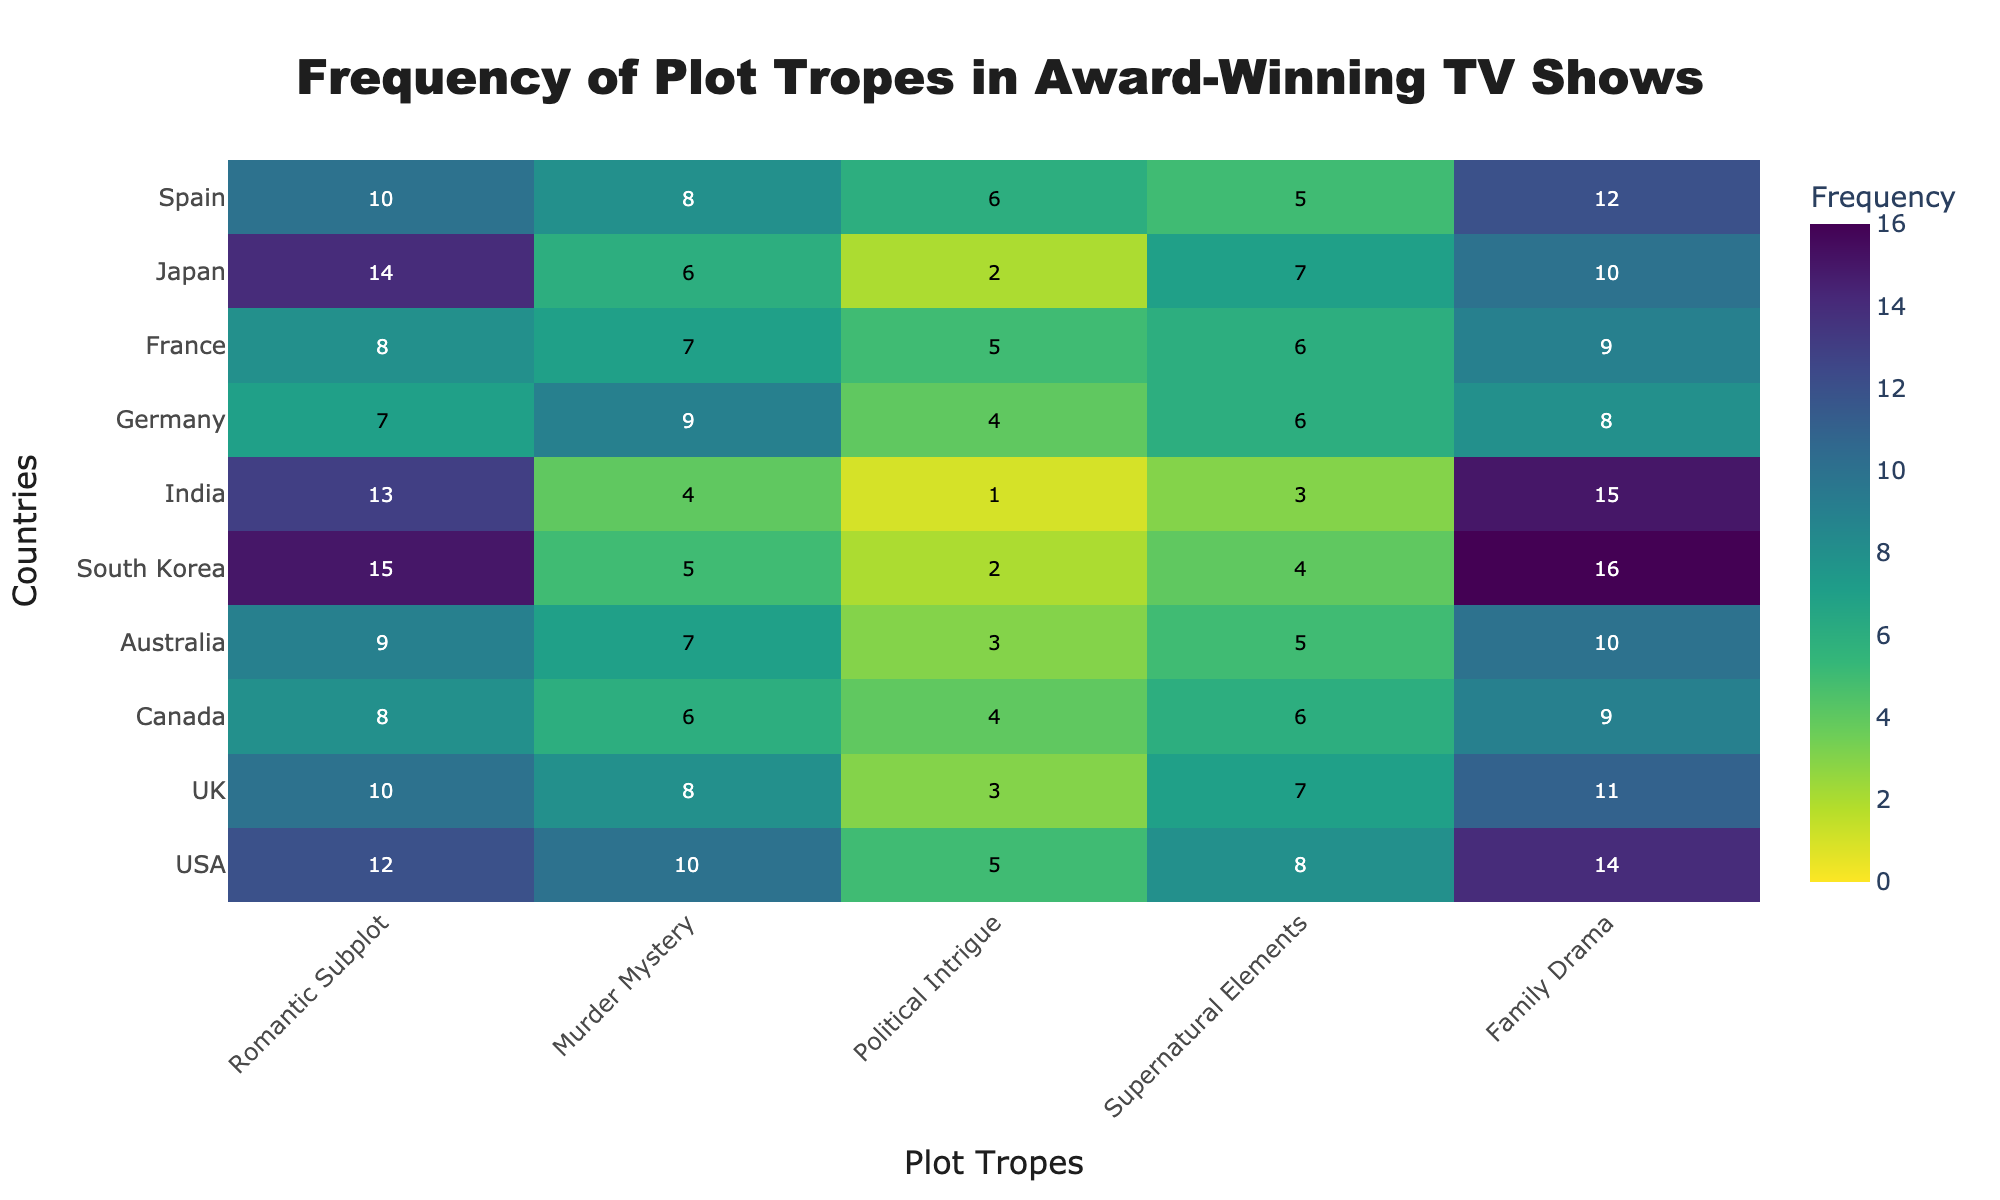what is the title of the figure? The title of a heatmap typically appears at the top center of the figure. In this case, based on the provided code, the title is indicated as 'Frequency of Plot Tropes in Award-Winning TV Shows'.
Answer: Frequency of Plot Tropes in Award-Winning TV Shows What is the most common trope in South Korean TV shows? To determine the most common trope, look for the highest value in the row corresponding to South Korea. For South Korea: Romantic Subplot (15), Murder Mystery (5), Political Intrigue (2), Supernatural Elements (4), Family Drama (16). The highest value is 16 in the Family Drama column.
Answer: Family Drama Which country features supernatural elements the most frequently? To find this, look for the highest value in the Supernatural Elements column. The frequencies for Supernatural Elements are USA (8), UK (7), Canada (6), Australia (5), South Korea (4), India (3), Germany (6), France (6), Japan (7), Spain (5). The highest value is 8 for USA.
Answer: USA What is the difference in frequency of romantic subplots between the country with the highest and the one with the lowest frequency in this trope? Locate the highest and lowest values in the Romantic Subplot column. The values are USA (12), UK (10), Canada (8), Australia (9), South Korea (15), India (13), Germany (7), France (8), Japan (14), Spain (10). The highest is 15 (South Korea), and the lowest is 7 (Germany). The difference is 15 - 7.
Answer: 8 Which country has the lowest frequency of political intrigue? Look for the smallest value in the Political Intrigue column. The values are USA (5), UK (3), Canada (4), Australia (3), South Korea (2), India (1), Germany (4), France (5), Japan (2), Spain (6). The smallest value is 1 for India.
Answer: India On average, how often do Australian TV shows feature family drama? Identify the frequency value for Family Drama in Australia. The value is 10. Since this is a single piece of data, the average is simply that value.
Answer: 10 Are murder mysteries more common in UK or Germany? Compare the values in the Murder Mystery column for the UK and Germany. UK has 8 and Germany has 9.
Answer: Germany 